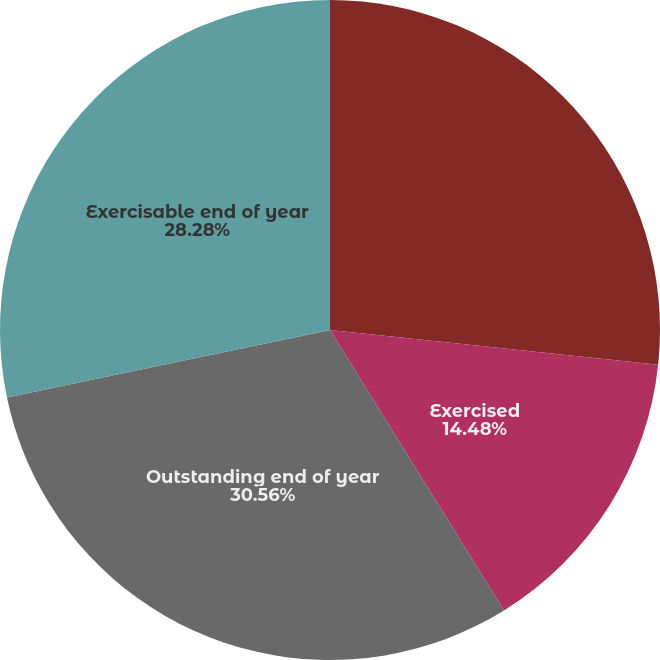Convert chart. <chart><loc_0><loc_0><loc_500><loc_500><pie_chart><fcel>Outstanding beginning of year<fcel>Exercised<fcel>Outstanding end of year<fcel>Exercisable end of year<nl><fcel>26.68%<fcel>14.48%<fcel>30.56%<fcel>28.28%<nl></chart> 